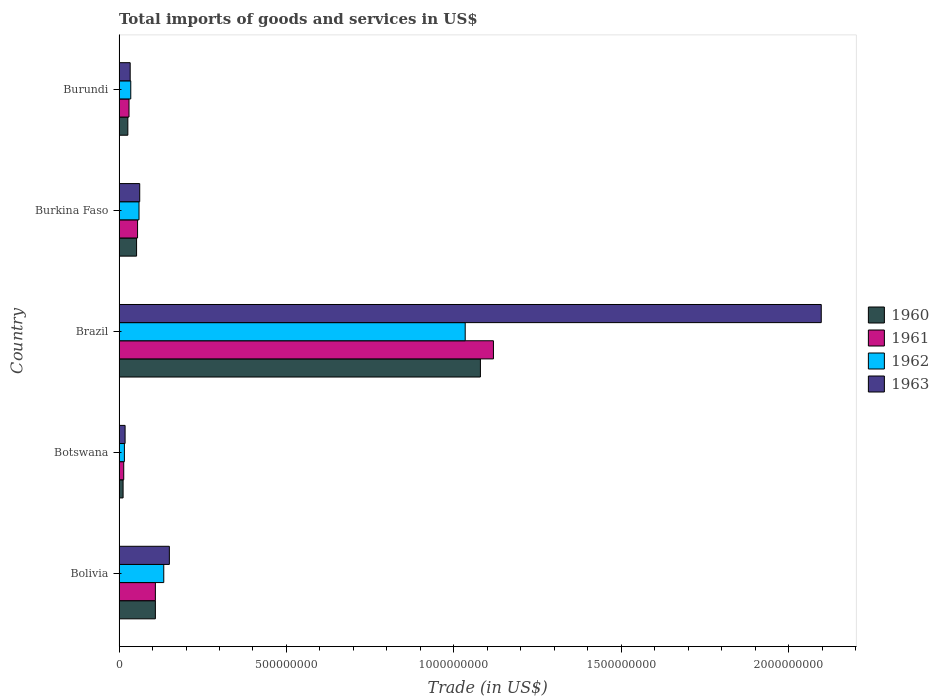How many different coloured bars are there?
Provide a succinct answer. 4. How many groups of bars are there?
Provide a succinct answer. 5. Are the number of bars per tick equal to the number of legend labels?
Your response must be concise. Yes. How many bars are there on the 5th tick from the top?
Provide a short and direct response. 4. How many bars are there on the 4th tick from the bottom?
Give a very brief answer. 4. What is the label of the 1st group of bars from the top?
Make the answer very short. Burundi. In how many cases, is the number of bars for a given country not equal to the number of legend labels?
Make the answer very short. 0. What is the total imports of goods and services in 1961 in Burkina Faso?
Keep it short and to the point. 5.53e+07. Across all countries, what is the maximum total imports of goods and services in 1961?
Your answer should be compact. 1.12e+09. Across all countries, what is the minimum total imports of goods and services in 1960?
Provide a succinct answer. 1.21e+07. In which country was the total imports of goods and services in 1963 minimum?
Provide a succinct answer. Botswana. What is the total total imports of goods and services in 1963 in the graph?
Offer a very short reply. 2.36e+09. What is the difference between the total imports of goods and services in 1962 in Botswana and that in Brazil?
Your answer should be compact. -1.02e+09. What is the difference between the total imports of goods and services in 1960 in Burundi and the total imports of goods and services in 1962 in Brazil?
Your answer should be very brief. -1.01e+09. What is the average total imports of goods and services in 1961 per country?
Your answer should be very brief. 2.65e+08. What is the difference between the total imports of goods and services in 1961 and total imports of goods and services in 1963 in Burkina Faso?
Make the answer very short. -6.44e+06. What is the ratio of the total imports of goods and services in 1963 in Bolivia to that in Burundi?
Offer a terse response. 4.52. Is the difference between the total imports of goods and services in 1961 in Botswana and Burundi greater than the difference between the total imports of goods and services in 1963 in Botswana and Burundi?
Your answer should be very brief. No. What is the difference between the highest and the second highest total imports of goods and services in 1963?
Your response must be concise. 1.95e+09. What is the difference between the highest and the lowest total imports of goods and services in 1960?
Offer a terse response. 1.07e+09. In how many countries, is the total imports of goods and services in 1962 greater than the average total imports of goods and services in 1962 taken over all countries?
Make the answer very short. 1. Is the sum of the total imports of goods and services in 1962 in Botswana and Burkina Faso greater than the maximum total imports of goods and services in 1963 across all countries?
Keep it short and to the point. No. What does the 4th bar from the bottom in Bolivia represents?
Ensure brevity in your answer.  1963. Is it the case that in every country, the sum of the total imports of goods and services in 1963 and total imports of goods and services in 1961 is greater than the total imports of goods and services in 1962?
Give a very brief answer. Yes. How many bars are there?
Your answer should be compact. 20. Are the values on the major ticks of X-axis written in scientific E-notation?
Provide a short and direct response. No. Does the graph contain grids?
Offer a terse response. No. Where does the legend appear in the graph?
Provide a succinct answer. Center right. How many legend labels are there?
Offer a very short reply. 4. How are the legend labels stacked?
Provide a succinct answer. Vertical. What is the title of the graph?
Make the answer very short. Total imports of goods and services in US$. What is the label or title of the X-axis?
Offer a terse response. Trade (in US$). What is the label or title of the Y-axis?
Give a very brief answer. Country. What is the Trade (in US$) in 1960 in Bolivia?
Provide a short and direct response. 1.09e+08. What is the Trade (in US$) of 1961 in Bolivia?
Offer a terse response. 1.09e+08. What is the Trade (in US$) in 1962 in Bolivia?
Provide a succinct answer. 1.34e+08. What is the Trade (in US$) of 1963 in Bolivia?
Give a very brief answer. 1.50e+08. What is the Trade (in US$) in 1960 in Botswana?
Provide a succinct answer. 1.21e+07. What is the Trade (in US$) of 1961 in Botswana?
Give a very brief answer. 1.40e+07. What is the Trade (in US$) of 1962 in Botswana?
Keep it short and to the point. 1.60e+07. What is the Trade (in US$) of 1963 in Botswana?
Give a very brief answer. 1.80e+07. What is the Trade (in US$) of 1960 in Brazil?
Provide a succinct answer. 1.08e+09. What is the Trade (in US$) in 1961 in Brazil?
Your answer should be very brief. 1.12e+09. What is the Trade (in US$) of 1962 in Brazil?
Provide a succinct answer. 1.03e+09. What is the Trade (in US$) in 1963 in Brazil?
Ensure brevity in your answer.  2.10e+09. What is the Trade (in US$) in 1960 in Burkina Faso?
Ensure brevity in your answer.  5.23e+07. What is the Trade (in US$) of 1961 in Burkina Faso?
Make the answer very short. 5.53e+07. What is the Trade (in US$) of 1962 in Burkina Faso?
Your response must be concise. 5.96e+07. What is the Trade (in US$) in 1963 in Burkina Faso?
Keep it short and to the point. 6.17e+07. What is the Trade (in US$) of 1960 in Burundi?
Offer a very short reply. 2.62e+07. What is the Trade (in US$) in 1961 in Burundi?
Your response must be concise. 2.98e+07. What is the Trade (in US$) of 1962 in Burundi?
Ensure brevity in your answer.  3.50e+07. What is the Trade (in US$) in 1963 in Burundi?
Make the answer very short. 3.32e+07. Across all countries, what is the maximum Trade (in US$) of 1960?
Your answer should be compact. 1.08e+09. Across all countries, what is the maximum Trade (in US$) of 1961?
Your answer should be compact. 1.12e+09. Across all countries, what is the maximum Trade (in US$) of 1962?
Your response must be concise. 1.03e+09. Across all countries, what is the maximum Trade (in US$) of 1963?
Make the answer very short. 2.10e+09. Across all countries, what is the minimum Trade (in US$) of 1960?
Your answer should be very brief. 1.21e+07. Across all countries, what is the minimum Trade (in US$) of 1961?
Your answer should be compact. 1.40e+07. Across all countries, what is the minimum Trade (in US$) of 1962?
Your response must be concise. 1.60e+07. Across all countries, what is the minimum Trade (in US$) of 1963?
Provide a succinct answer. 1.80e+07. What is the total Trade (in US$) of 1960 in the graph?
Provide a short and direct response. 1.28e+09. What is the total Trade (in US$) of 1961 in the graph?
Offer a terse response. 1.33e+09. What is the total Trade (in US$) in 1962 in the graph?
Ensure brevity in your answer.  1.28e+09. What is the total Trade (in US$) in 1963 in the graph?
Make the answer very short. 2.36e+09. What is the difference between the Trade (in US$) of 1960 in Bolivia and that in Botswana?
Your answer should be compact. 9.65e+07. What is the difference between the Trade (in US$) in 1961 in Bolivia and that in Botswana?
Ensure brevity in your answer.  9.45e+07. What is the difference between the Trade (in US$) of 1962 in Bolivia and that in Botswana?
Offer a very short reply. 1.18e+08. What is the difference between the Trade (in US$) in 1963 in Bolivia and that in Botswana?
Your response must be concise. 1.32e+08. What is the difference between the Trade (in US$) in 1960 in Bolivia and that in Brazil?
Offer a terse response. -9.71e+08. What is the difference between the Trade (in US$) of 1961 in Bolivia and that in Brazil?
Give a very brief answer. -1.01e+09. What is the difference between the Trade (in US$) of 1962 in Bolivia and that in Brazil?
Your answer should be compact. -9.00e+08. What is the difference between the Trade (in US$) in 1963 in Bolivia and that in Brazil?
Keep it short and to the point. -1.95e+09. What is the difference between the Trade (in US$) in 1960 in Bolivia and that in Burkina Faso?
Your response must be concise. 5.62e+07. What is the difference between the Trade (in US$) of 1961 in Bolivia and that in Burkina Faso?
Offer a very short reply. 5.32e+07. What is the difference between the Trade (in US$) in 1962 in Bolivia and that in Burkina Faso?
Offer a very short reply. 7.39e+07. What is the difference between the Trade (in US$) of 1963 in Bolivia and that in Burkina Faso?
Keep it short and to the point. 8.85e+07. What is the difference between the Trade (in US$) of 1960 in Bolivia and that in Burundi?
Your answer should be very brief. 8.23e+07. What is the difference between the Trade (in US$) of 1961 in Bolivia and that in Burundi?
Keep it short and to the point. 7.88e+07. What is the difference between the Trade (in US$) of 1962 in Bolivia and that in Burundi?
Your answer should be compact. 9.86e+07. What is the difference between the Trade (in US$) of 1963 in Bolivia and that in Burundi?
Provide a short and direct response. 1.17e+08. What is the difference between the Trade (in US$) of 1960 in Botswana and that in Brazil?
Provide a succinct answer. -1.07e+09. What is the difference between the Trade (in US$) of 1961 in Botswana and that in Brazil?
Ensure brevity in your answer.  -1.10e+09. What is the difference between the Trade (in US$) in 1962 in Botswana and that in Brazil?
Offer a very short reply. -1.02e+09. What is the difference between the Trade (in US$) of 1963 in Botswana and that in Brazil?
Provide a short and direct response. -2.08e+09. What is the difference between the Trade (in US$) of 1960 in Botswana and that in Burkina Faso?
Your response must be concise. -4.03e+07. What is the difference between the Trade (in US$) of 1961 in Botswana and that in Burkina Faso?
Make the answer very short. -4.13e+07. What is the difference between the Trade (in US$) in 1962 in Botswana and that in Burkina Faso?
Provide a short and direct response. -4.36e+07. What is the difference between the Trade (in US$) of 1963 in Botswana and that in Burkina Faso?
Keep it short and to the point. -4.37e+07. What is the difference between the Trade (in US$) of 1960 in Botswana and that in Burundi?
Offer a terse response. -1.42e+07. What is the difference between the Trade (in US$) of 1961 in Botswana and that in Burundi?
Your response must be concise. -1.58e+07. What is the difference between the Trade (in US$) of 1962 in Botswana and that in Burundi?
Offer a very short reply. -1.90e+07. What is the difference between the Trade (in US$) in 1963 in Botswana and that in Burundi?
Ensure brevity in your answer.  -1.52e+07. What is the difference between the Trade (in US$) of 1960 in Brazil and that in Burkina Faso?
Your answer should be compact. 1.03e+09. What is the difference between the Trade (in US$) of 1961 in Brazil and that in Burkina Faso?
Your answer should be compact. 1.06e+09. What is the difference between the Trade (in US$) of 1962 in Brazil and that in Burkina Faso?
Offer a terse response. 9.74e+08. What is the difference between the Trade (in US$) of 1963 in Brazil and that in Burkina Faso?
Provide a succinct answer. 2.04e+09. What is the difference between the Trade (in US$) of 1960 in Brazil and that in Burundi?
Make the answer very short. 1.05e+09. What is the difference between the Trade (in US$) of 1961 in Brazil and that in Burundi?
Make the answer very short. 1.09e+09. What is the difference between the Trade (in US$) in 1962 in Brazil and that in Burundi?
Offer a very short reply. 9.99e+08. What is the difference between the Trade (in US$) of 1963 in Brazil and that in Burundi?
Your response must be concise. 2.06e+09. What is the difference between the Trade (in US$) in 1960 in Burkina Faso and that in Burundi?
Ensure brevity in your answer.  2.61e+07. What is the difference between the Trade (in US$) in 1961 in Burkina Faso and that in Burundi?
Offer a very short reply. 2.56e+07. What is the difference between the Trade (in US$) of 1962 in Burkina Faso and that in Burundi?
Keep it short and to the point. 2.46e+07. What is the difference between the Trade (in US$) of 1963 in Burkina Faso and that in Burundi?
Offer a very short reply. 2.85e+07. What is the difference between the Trade (in US$) of 1960 in Bolivia and the Trade (in US$) of 1961 in Botswana?
Ensure brevity in your answer.  9.45e+07. What is the difference between the Trade (in US$) of 1960 in Bolivia and the Trade (in US$) of 1962 in Botswana?
Your answer should be very brief. 9.25e+07. What is the difference between the Trade (in US$) of 1960 in Bolivia and the Trade (in US$) of 1963 in Botswana?
Provide a short and direct response. 9.05e+07. What is the difference between the Trade (in US$) of 1961 in Bolivia and the Trade (in US$) of 1962 in Botswana?
Your answer should be very brief. 9.25e+07. What is the difference between the Trade (in US$) in 1961 in Bolivia and the Trade (in US$) in 1963 in Botswana?
Provide a short and direct response. 9.05e+07. What is the difference between the Trade (in US$) in 1962 in Bolivia and the Trade (in US$) in 1963 in Botswana?
Keep it short and to the point. 1.16e+08. What is the difference between the Trade (in US$) of 1960 in Bolivia and the Trade (in US$) of 1961 in Brazil?
Offer a very short reply. -1.01e+09. What is the difference between the Trade (in US$) in 1960 in Bolivia and the Trade (in US$) in 1962 in Brazil?
Give a very brief answer. -9.25e+08. What is the difference between the Trade (in US$) of 1960 in Bolivia and the Trade (in US$) of 1963 in Brazil?
Give a very brief answer. -1.99e+09. What is the difference between the Trade (in US$) of 1961 in Bolivia and the Trade (in US$) of 1962 in Brazil?
Make the answer very short. -9.25e+08. What is the difference between the Trade (in US$) of 1961 in Bolivia and the Trade (in US$) of 1963 in Brazil?
Your answer should be very brief. -1.99e+09. What is the difference between the Trade (in US$) in 1962 in Bolivia and the Trade (in US$) in 1963 in Brazil?
Ensure brevity in your answer.  -1.96e+09. What is the difference between the Trade (in US$) of 1960 in Bolivia and the Trade (in US$) of 1961 in Burkina Faso?
Give a very brief answer. 5.32e+07. What is the difference between the Trade (in US$) of 1960 in Bolivia and the Trade (in US$) of 1962 in Burkina Faso?
Give a very brief answer. 4.89e+07. What is the difference between the Trade (in US$) of 1960 in Bolivia and the Trade (in US$) of 1963 in Burkina Faso?
Your response must be concise. 4.68e+07. What is the difference between the Trade (in US$) in 1961 in Bolivia and the Trade (in US$) in 1962 in Burkina Faso?
Provide a succinct answer. 4.89e+07. What is the difference between the Trade (in US$) of 1961 in Bolivia and the Trade (in US$) of 1963 in Burkina Faso?
Provide a short and direct response. 4.68e+07. What is the difference between the Trade (in US$) in 1962 in Bolivia and the Trade (in US$) in 1963 in Burkina Faso?
Provide a short and direct response. 7.18e+07. What is the difference between the Trade (in US$) in 1960 in Bolivia and the Trade (in US$) in 1961 in Burundi?
Your response must be concise. 7.88e+07. What is the difference between the Trade (in US$) of 1960 in Bolivia and the Trade (in US$) of 1962 in Burundi?
Offer a very short reply. 7.35e+07. What is the difference between the Trade (in US$) of 1960 in Bolivia and the Trade (in US$) of 1963 in Burundi?
Your answer should be very brief. 7.53e+07. What is the difference between the Trade (in US$) of 1961 in Bolivia and the Trade (in US$) of 1962 in Burundi?
Keep it short and to the point. 7.35e+07. What is the difference between the Trade (in US$) in 1961 in Bolivia and the Trade (in US$) in 1963 in Burundi?
Offer a terse response. 7.53e+07. What is the difference between the Trade (in US$) in 1962 in Bolivia and the Trade (in US$) in 1963 in Burundi?
Your answer should be very brief. 1.00e+08. What is the difference between the Trade (in US$) in 1960 in Botswana and the Trade (in US$) in 1961 in Brazil?
Keep it short and to the point. -1.11e+09. What is the difference between the Trade (in US$) in 1960 in Botswana and the Trade (in US$) in 1962 in Brazil?
Your response must be concise. -1.02e+09. What is the difference between the Trade (in US$) of 1960 in Botswana and the Trade (in US$) of 1963 in Brazil?
Ensure brevity in your answer.  -2.09e+09. What is the difference between the Trade (in US$) in 1961 in Botswana and the Trade (in US$) in 1962 in Brazil?
Your answer should be compact. -1.02e+09. What is the difference between the Trade (in US$) in 1961 in Botswana and the Trade (in US$) in 1963 in Brazil?
Provide a succinct answer. -2.08e+09. What is the difference between the Trade (in US$) in 1962 in Botswana and the Trade (in US$) in 1963 in Brazil?
Offer a very short reply. -2.08e+09. What is the difference between the Trade (in US$) of 1960 in Botswana and the Trade (in US$) of 1961 in Burkina Faso?
Your answer should be compact. -4.32e+07. What is the difference between the Trade (in US$) in 1960 in Botswana and the Trade (in US$) in 1962 in Burkina Faso?
Ensure brevity in your answer.  -4.76e+07. What is the difference between the Trade (in US$) of 1960 in Botswana and the Trade (in US$) of 1963 in Burkina Faso?
Ensure brevity in your answer.  -4.97e+07. What is the difference between the Trade (in US$) of 1961 in Botswana and the Trade (in US$) of 1962 in Burkina Faso?
Keep it short and to the point. -4.56e+07. What is the difference between the Trade (in US$) of 1961 in Botswana and the Trade (in US$) of 1963 in Burkina Faso?
Provide a succinct answer. -4.78e+07. What is the difference between the Trade (in US$) of 1962 in Botswana and the Trade (in US$) of 1963 in Burkina Faso?
Ensure brevity in your answer.  -4.58e+07. What is the difference between the Trade (in US$) in 1960 in Botswana and the Trade (in US$) in 1961 in Burundi?
Keep it short and to the point. -1.77e+07. What is the difference between the Trade (in US$) in 1960 in Botswana and the Trade (in US$) in 1962 in Burundi?
Keep it short and to the point. -2.29e+07. What is the difference between the Trade (in US$) of 1960 in Botswana and the Trade (in US$) of 1963 in Burundi?
Your answer should be compact. -2.12e+07. What is the difference between the Trade (in US$) of 1961 in Botswana and the Trade (in US$) of 1962 in Burundi?
Your answer should be very brief. -2.10e+07. What is the difference between the Trade (in US$) of 1961 in Botswana and the Trade (in US$) of 1963 in Burundi?
Keep it short and to the point. -1.93e+07. What is the difference between the Trade (in US$) of 1962 in Botswana and the Trade (in US$) of 1963 in Burundi?
Provide a succinct answer. -1.73e+07. What is the difference between the Trade (in US$) in 1960 in Brazil and the Trade (in US$) in 1961 in Burkina Faso?
Keep it short and to the point. 1.02e+09. What is the difference between the Trade (in US$) in 1960 in Brazil and the Trade (in US$) in 1962 in Burkina Faso?
Provide a succinct answer. 1.02e+09. What is the difference between the Trade (in US$) in 1960 in Brazil and the Trade (in US$) in 1963 in Burkina Faso?
Your answer should be compact. 1.02e+09. What is the difference between the Trade (in US$) in 1961 in Brazil and the Trade (in US$) in 1962 in Burkina Faso?
Ensure brevity in your answer.  1.06e+09. What is the difference between the Trade (in US$) of 1961 in Brazil and the Trade (in US$) of 1963 in Burkina Faso?
Offer a very short reply. 1.06e+09. What is the difference between the Trade (in US$) in 1962 in Brazil and the Trade (in US$) in 1963 in Burkina Faso?
Offer a very short reply. 9.72e+08. What is the difference between the Trade (in US$) of 1960 in Brazil and the Trade (in US$) of 1961 in Burundi?
Your answer should be very brief. 1.05e+09. What is the difference between the Trade (in US$) in 1960 in Brazil and the Trade (in US$) in 1962 in Burundi?
Offer a terse response. 1.04e+09. What is the difference between the Trade (in US$) of 1960 in Brazil and the Trade (in US$) of 1963 in Burundi?
Give a very brief answer. 1.05e+09. What is the difference between the Trade (in US$) in 1961 in Brazil and the Trade (in US$) in 1962 in Burundi?
Keep it short and to the point. 1.08e+09. What is the difference between the Trade (in US$) of 1961 in Brazil and the Trade (in US$) of 1963 in Burundi?
Offer a terse response. 1.09e+09. What is the difference between the Trade (in US$) of 1962 in Brazil and the Trade (in US$) of 1963 in Burundi?
Your answer should be compact. 1.00e+09. What is the difference between the Trade (in US$) of 1960 in Burkina Faso and the Trade (in US$) of 1961 in Burundi?
Your answer should be compact. 2.26e+07. What is the difference between the Trade (in US$) of 1960 in Burkina Faso and the Trade (in US$) of 1962 in Burundi?
Offer a terse response. 1.73e+07. What is the difference between the Trade (in US$) of 1960 in Burkina Faso and the Trade (in US$) of 1963 in Burundi?
Offer a very short reply. 1.91e+07. What is the difference between the Trade (in US$) in 1961 in Burkina Faso and the Trade (in US$) in 1962 in Burundi?
Give a very brief answer. 2.03e+07. What is the difference between the Trade (in US$) in 1961 in Burkina Faso and the Trade (in US$) in 1963 in Burundi?
Ensure brevity in your answer.  2.21e+07. What is the difference between the Trade (in US$) of 1962 in Burkina Faso and the Trade (in US$) of 1963 in Burundi?
Give a very brief answer. 2.64e+07. What is the average Trade (in US$) of 1960 per country?
Make the answer very short. 2.56e+08. What is the average Trade (in US$) of 1961 per country?
Give a very brief answer. 2.65e+08. What is the average Trade (in US$) in 1962 per country?
Offer a very short reply. 2.56e+08. What is the average Trade (in US$) of 1963 per country?
Ensure brevity in your answer.  4.72e+08. What is the difference between the Trade (in US$) of 1960 and Trade (in US$) of 1961 in Bolivia?
Your answer should be very brief. 0. What is the difference between the Trade (in US$) of 1960 and Trade (in US$) of 1962 in Bolivia?
Offer a very short reply. -2.50e+07. What is the difference between the Trade (in US$) of 1960 and Trade (in US$) of 1963 in Bolivia?
Give a very brief answer. -4.17e+07. What is the difference between the Trade (in US$) of 1961 and Trade (in US$) of 1962 in Bolivia?
Keep it short and to the point. -2.50e+07. What is the difference between the Trade (in US$) of 1961 and Trade (in US$) of 1963 in Bolivia?
Your response must be concise. -4.17e+07. What is the difference between the Trade (in US$) in 1962 and Trade (in US$) in 1963 in Bolivia?
Provide a short and direct response. -1.67e+07. What is the difference between the Trade (in US$) of 1960 and Trade (in US$) of 1961 in Botswana?
Provide a short and direct response. -1.94e+06. What is the difference between the Trade (in US$) of 1960 and Trade (in US$) of 1962 in Botswana?
Provide a succinct answer. -3.93e+06. What is the difference between the Trade (in US$) in 1960 and Trade (in US$) in 1963 in Botswana?
Provide a succinct answer. -5.98e+06. What is the difference between the Trade (in US$) of 1961 and Trade (in US$) of 1962 in Botswana?
Your answer should be very brief. -1.99e+06. What is the difference between the Trade (in US$) in 1961 and Trade (in US$) in 1963 in Botswana?
Make the answer very short. -4.04e+06. What is the difference between the Trade (in US$) in 1962 and Trade (in US$) in 1963 in Botswana?
Provide a succinct answer. -2.05e+06. What is the difference between the Trade (in US$) of 1960 and Trade (in US$) of 1961 in Brazil?
Your response must be concise. -3.89e+07. What is the difference between the Trade (in US$) of 1960 and Trade (in US$) of 1962 in Brazil?
Your answer should be compact. 4.54e+07. What is the difference between the Trade (in US$) of 1960 and Trade (in US$) of 1963 in Brazil?
Keep it short and to the point. -1.02e+09. What is the difference between the Trade (in US$) in 1961 and Trade (in US$) in 1962 in Brazil?
Offer a very short reply. 8.43e+07. What is the difference between the Trade (in US$) of 1961 and Trade (in US$) of 1963 in Brazil?
Your answer should be very brief. -9.79e+08. What is the difference between the Trade (in US$) of 1962 and Trade (in US$) of 1963 in Brazil?
Offer a terse response. -1.06e+09. What is the difference between the Trade (in US$) of 1960 and Trade (in US$) of 1961 in Burkina Faso?
Keep it short and to the point. -2.96e+06. What is the difference between the Trade (in US$) in 1960 and Trade (in US$) in 1962 in Burkina Faso?
Offer a very short reply. -7.27e+06. What is the difference between the Trade (in US$) in 1960 and Trade (in US$) in 1963 in Burkina Faso?
Provide a short and direct response. -9.40e+06. What is the difference between the Trade (in US$) of 1961 and Trade (in US$) of 1962 in Burkina Faso?
Your response must be concise. -4.31e+06. What is the difference between the Trade (in US$) in 1961 and Trade (in US$) in 1963 in Burkina Faso?
Ensure brevity in your answer.  -6.44e+06. What is the difference between the Trade (in US$) of 1962 and Trade (in US$) of 1963 in Burkina Faso?
Keep it short and to the point. -2.13e+06. What is the difference between the Trade (in US$) in 1960 and Trade (in US$) in 1961 in Burundi?
Make the answer very short. -3.50e+06. What is the difference between the Trade (in US$) of 1960 and Trade (in US$) of 1962 in Burundi?
Offer a terse response. -8.75e+06. What is the difference between the Trade (in US$) in 1960 and Trade (in US$) in 1963 in Burundi?
Your response must be concise. -7.00e+06. What is the difference between the Trade (in US$) in 1961 and Trade (in US$) in 1962 in Burundi?
Your answer should be compact. -5.25e+06. What is the difference between the Trade (in US$) in 1961 and Trade (in US$) in 1963 in Burundi?
Keep it short and to the point. -3.50e+06. What is the difference between the Trade (in US$) in 1962 and Trade (in US$) in 1963 in Burundi?
Provide a short and direct response. 1.75e+06. What is the ratio of the Trade (in US$) of 1960 in Bolivia to that in Botswana?
Ensure brevity in your answer.  9. What is the ratio of the Trade (in US$) in 1961 in Bolivia to that in Botswana?
Keep it short and to the point. 7.76. What is the ratio of the Trade (in US$) of 1962 in Bolivia to that in Botswana?
Offer a very short reply. 8.36. What is the ratio of the Trade (in US$) in 1963 in Bolivia to that in Botswana?
Make the answer very short. 8.33. What is the ratio of the Trade (in US$) of 1960 in Bolivia to that in Brazil?
Your answer should be compact. 0.1. What is the ratio of the Trade (in US$) in 1961 in Bolivia to that in Brazil?
Offer a very short reply. 0.1. What is the ratio of the Trade (in US$) of 1962 in Bolivia to that in Brazil?
Your response must be concise. 0.13. What is the ratio of the Trade (in US$) in 1963 in Bolivia to that in Brazil?
Make the answer very short. 0.07. What is the ratio of the Trade (in US$) of 1960 in Bolivia to that in Burkina Faso?
Make the answer very short. 2.07. What is the ratio of the Trade (in US$) of 1961 in Bolivia to that in Burkina Faso?
Your answer should be compact. 1.96. What is the ratio of the Trade (in US$) of 1962 in Bolivia to that in Burkina Faso?
Provide a succinct answer. 2.24. What is the ratio of the Trade (in US$) in 1963 in Bolivia to that in Burkina Faso?
Keep it short and to the point. 2.43. What is the ratio of the Trade (in US$) in 1960 in Bolivia to that in Burundi?
Offer a very short reply. 4.13. What is the ratio of the Trade (in US$) in 1961 in Bolivia to that in Burundi?
Provide a succinct answer. 3.65. What is the ratio of the Trade (in US$) in 1962 in Bolivia to that in Burundi?
Keep it short and to the point. 3.82. What is the ratio of the Trade (in US$) in 1963 in Bolivia to that in Burundi?
Provide a succinct answer. 4.52. What is the ratio of the Trade (in US$) in 1960 in Botswana to that in Brazil?
Your answer should be compact. 0.01. What is the ratio of the Trade (in US$) of 1961 in Botswana to that in Brazil?
Your answer should be compact. 0.01. What is the ratio of the Trade (in US$) in 1962 in Botswana to that in Brazil?
Offer a very short reply. 0.02. What is the ratio of the Trade (in US$) in 1963 in Botswana to that in Brazil?
Keep it short and to the point. 0.01. What is the ratio of the Trade (in US$) in 1960 in Botswana to that in Burkina Faso?
Make the answer very short. 0.23. What is the ratio of the Trade (in US$) in 1961 in Botswana to that in Burkina Faso?
Make the answer very short. 0.25. What is the ratio of the Trade (in US$) of 1962 in Botswana to that in Burkina Faso?
Ensure brevity in your answer.  0.27. What is the ratio of the Trade (in US$) in 1963 in Botswana to that in Burkina Faso?
Your answer should be compact. 0.29. What is the ratio of the Trade (in US$) in 1960 in Botswana to that in Burundi?
Make the answer very short. 0.46. What is the ratio of the Trade (in US$) in 1961 in Botswana to that in Burundi?
Provide a short and direct response. 0.47. What is the ratio of the Trade (in US$) in 1962 in Botswana to that in Burundi?
Offer a very short reply. 0.46. What is the ratio of the Trade (in US$) of 1963 in Botswana to that in Burundi?
Provide a short and direct response. 0.54. What is the ratio of the Trade (in US$) of 1960 in Brazil to that in Burkina Faso?
Provide a short and direct response. 20.62. What is the ratio of the Trade (in US$) of 1961 in Brazil to that in Burkina Faso?
Make the answer very short. 20.22. What is the ratio of the Trade (in US$) of 1962 in Brazil to that in Burkina Faso?
Give a very brief answer. 17.34. What is the ratio of the Trade (in US$) in 1963 in Brazil to that in Burkina Faso?
Offer a very short reply. 33.97. What is the ratio of the Trade (in US$) in 1960 in Brazil to that in Burundi?
Your answer should be compact. 41.12. What is the ratio of the Trade (in US$) of 1961 in Brazil to that in Burundi?
Provide a succinct answer. 37.59. What is the ratio of the Trade (in US$) of 1962 in Brazil to that in Burundi?
Your answer should be very brief. 29.54. What is the ratio of the Trade (in US$) in 1963 in Brazil to that in Burundi?
Offer a terse response. 63.08. What is the ratio of the Trade (in US$) of 1960 in Burkina Faso to that in Burundi?
Provide a succinct answer. 1.99. What is the ratio of the Trade (in US$) in 1961 in Burkina Faso to that in Burundi?
Offer a very short reply. 1.86. What is the ratio of the Trade (in US$) in 1962 in Burkina Faso to that in Burundi?
Provide a short and direct response. 1.7. What is the ratio of the Trade (in US$) of 1963 in Burkina Faso to that in Burundi?
Your response must be concise. 1.86. What is the difference between the highest and the second highest Trade (in US$) of 1960?
Give a very brief answer. 9.71e+08. What is the difference between the highest and the second highest Trade (in US$) of 1961?
Provide a short and direct response. 1.01e+09. What is the difference between the highest and the second highest Trade (in US$) in 1962?
Provide a succinct answer. 9.00e+08. What is the difference between the highest and the second highest Trade (in US$) of 1963?
Keep it short and to the point. 1.95e+09. What is the difference between the highest and the lowest Trade (in US$) in 1960?
Offer a very short reply. 1.07e+09. What is the difference between the highest and the lowest Trade (in US$) in 1961?
Ensure brevity in your answer.  1.10e+09. What is the difference between the highest and the lowest Trade (in US$) of 1962?
Ensure brevity in your answer.  1.02e+09. What is the difference between the highest and the lowest Trade (in US$) in 1963?
Offer a terse response. 2.08e+09. 